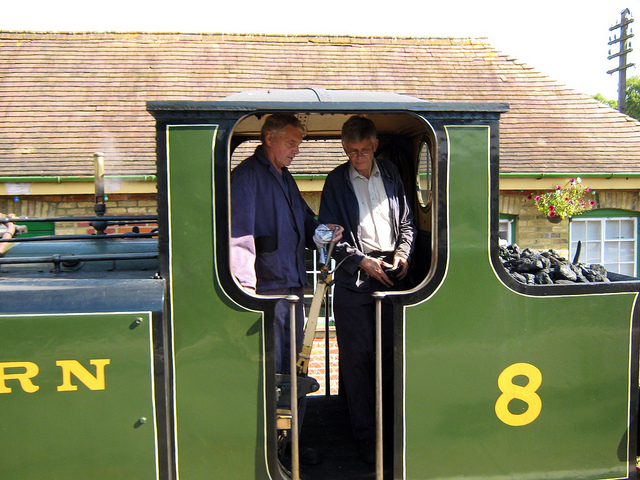Please transcribe the text information in this image. 8 R N 